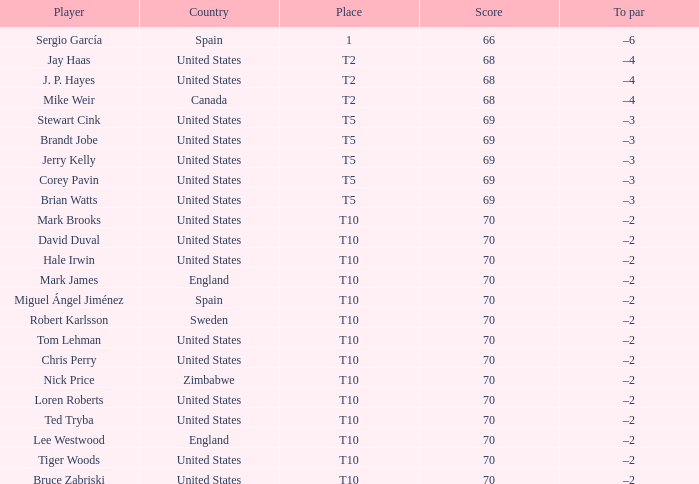What was the To par of the golfer that placed t5? –3, –3, –3, –3, –3. 